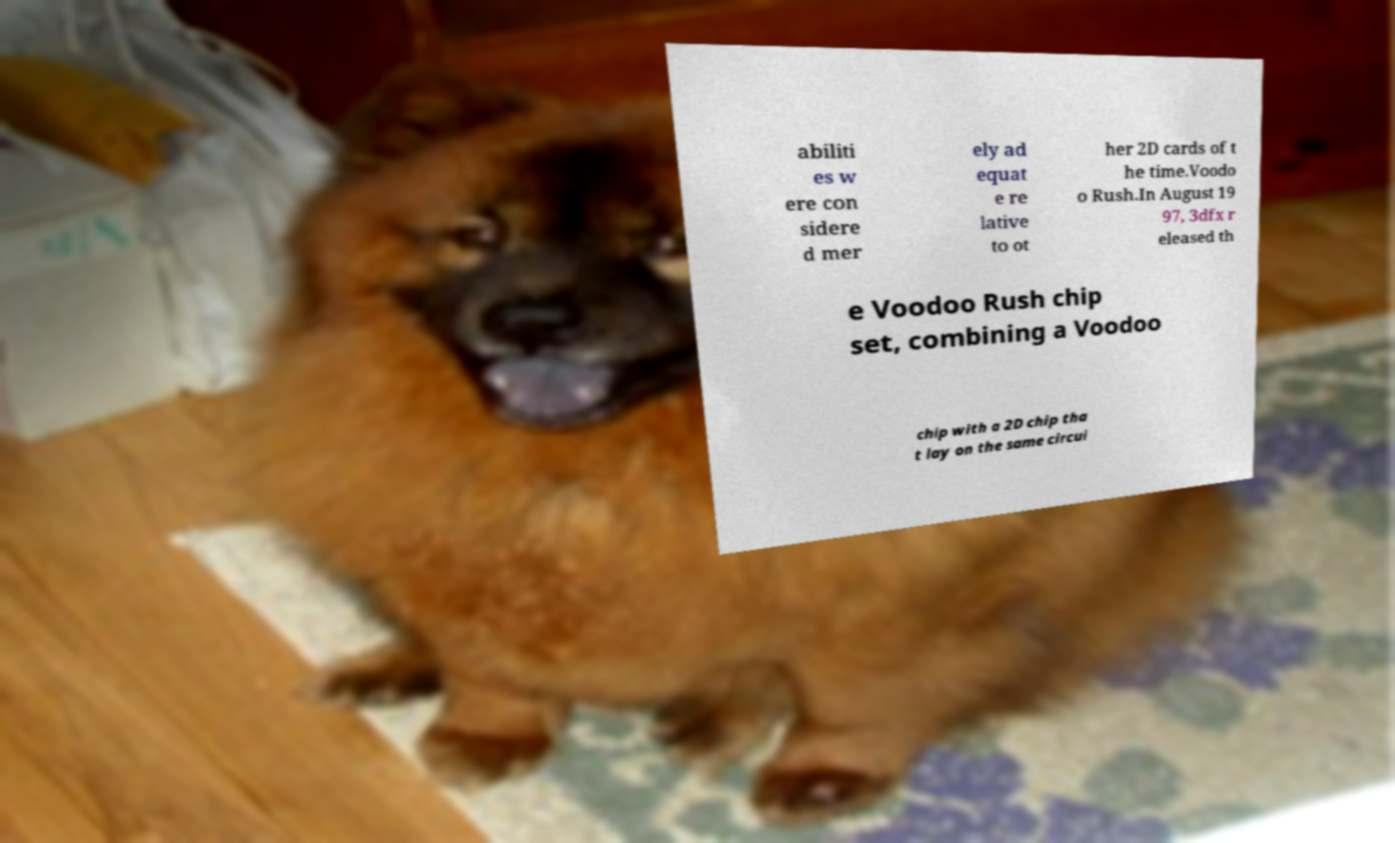Could you assist in decoding the text presented in this image and type it out clearly? abiliti es w ere con sidere d mer ely ad equat e re lative to ot her 2D cards of t he time.Voodo o Rush.In August 19 97, 3dfx r eleased th e Voodoo Rush chip set, combining a Voodoo chip with a 2D chip tha t lay on the same circui 